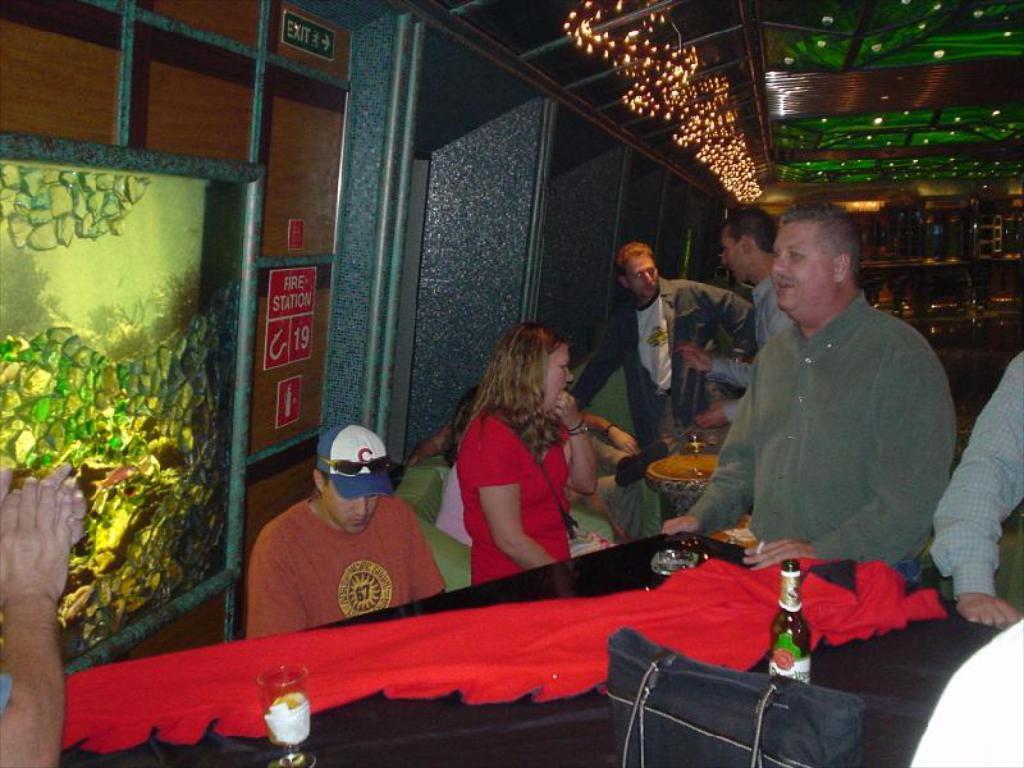How would you summarize this image in a sentence or two? The ceiling is so colorful and lights are hanging beside the ceiling. There is a painting over here on the left side, and a woman with red dress. A man standing beside the woman. There is a table with red cloth on it,with a beer bottle and a bag beside the bottle and there are several men stood and talking with each other in the behind. 